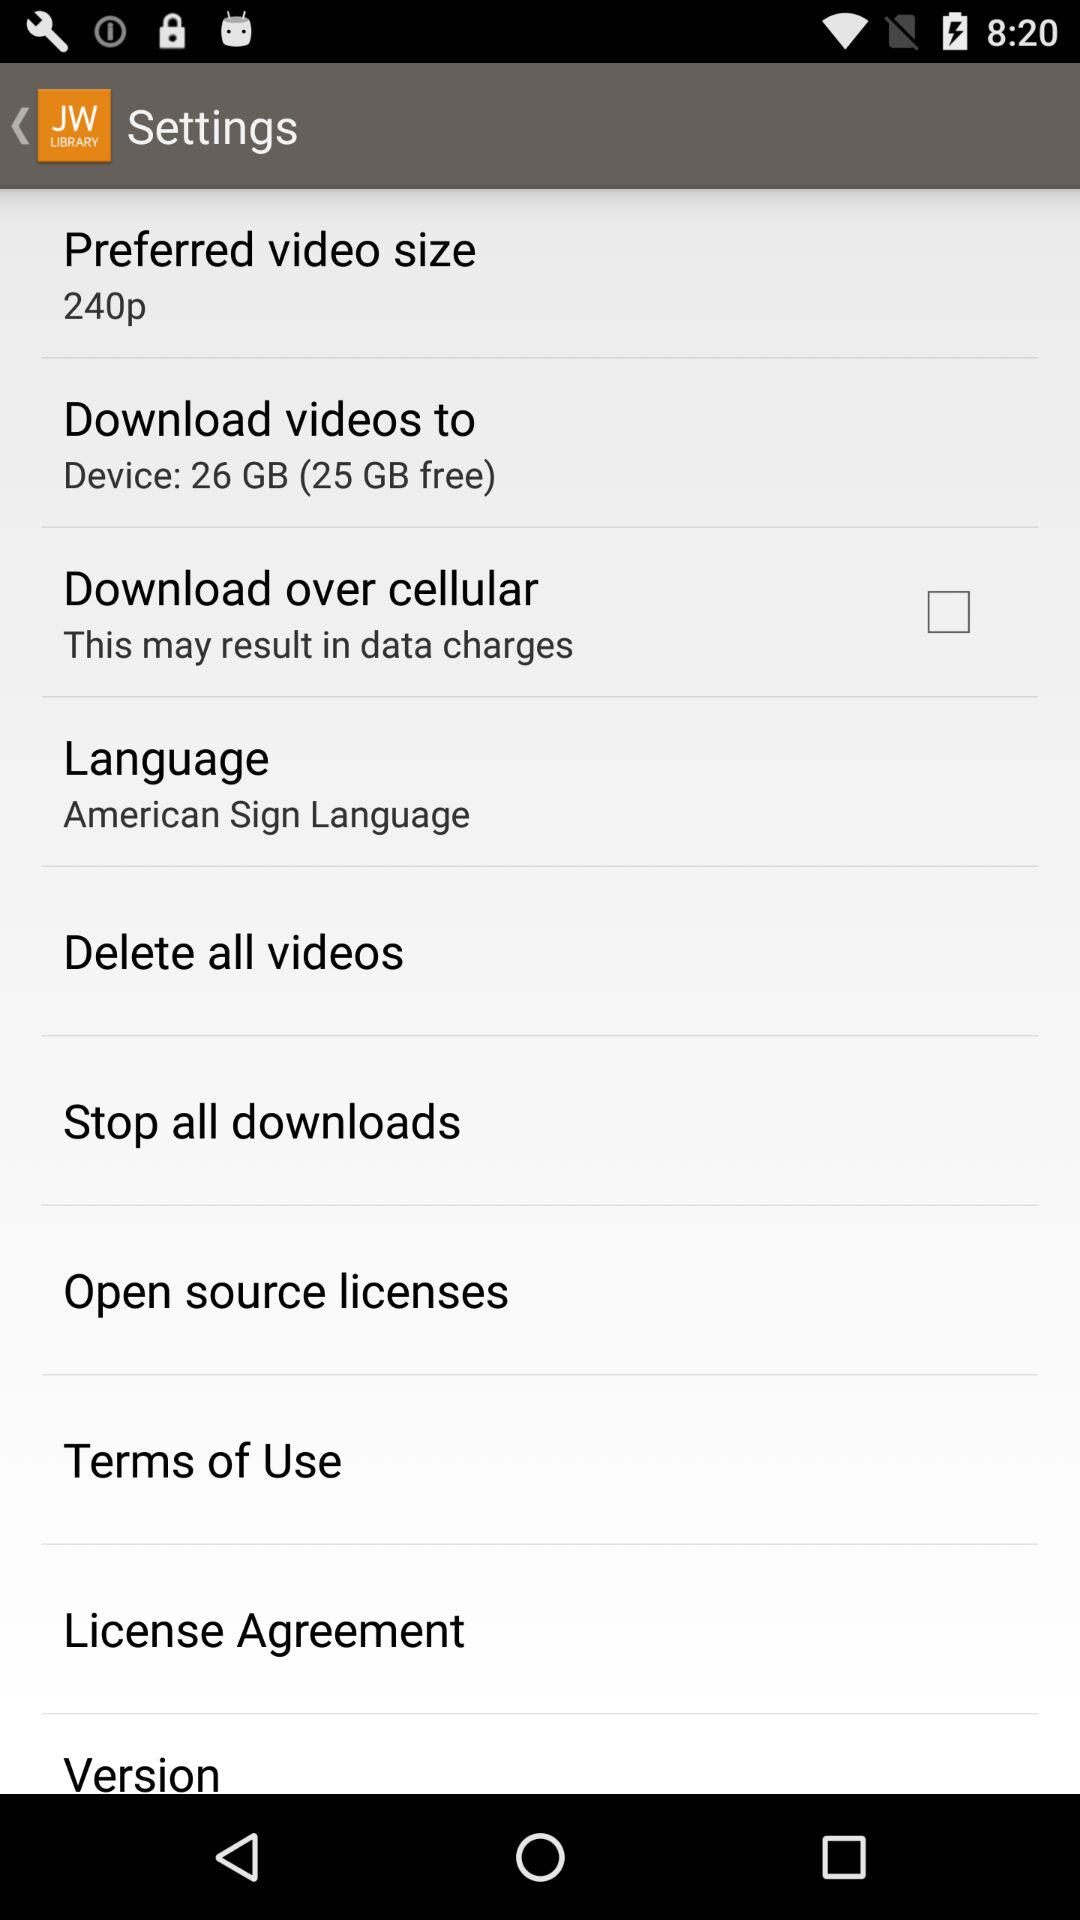Which language is selected? The selected language is "American Sign Language". 